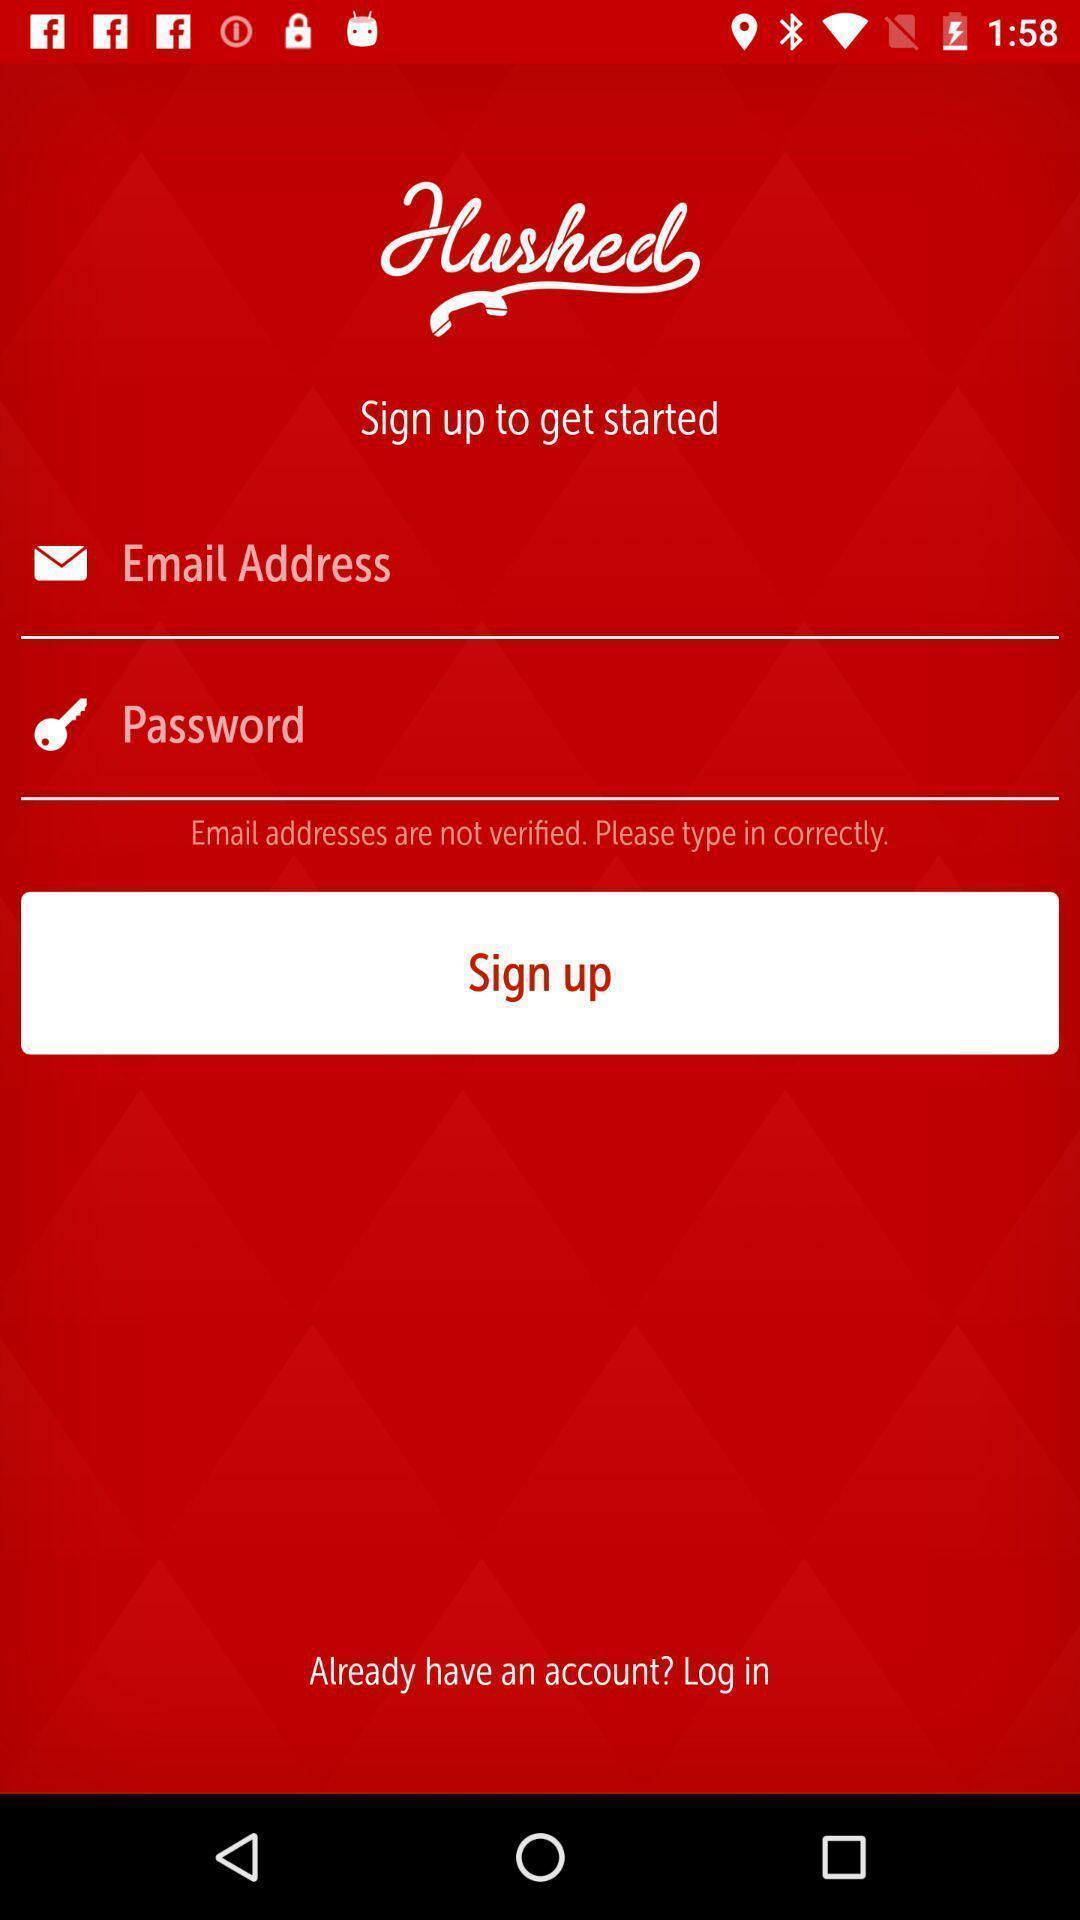Tell me what you see in this picture. Sign up page. 